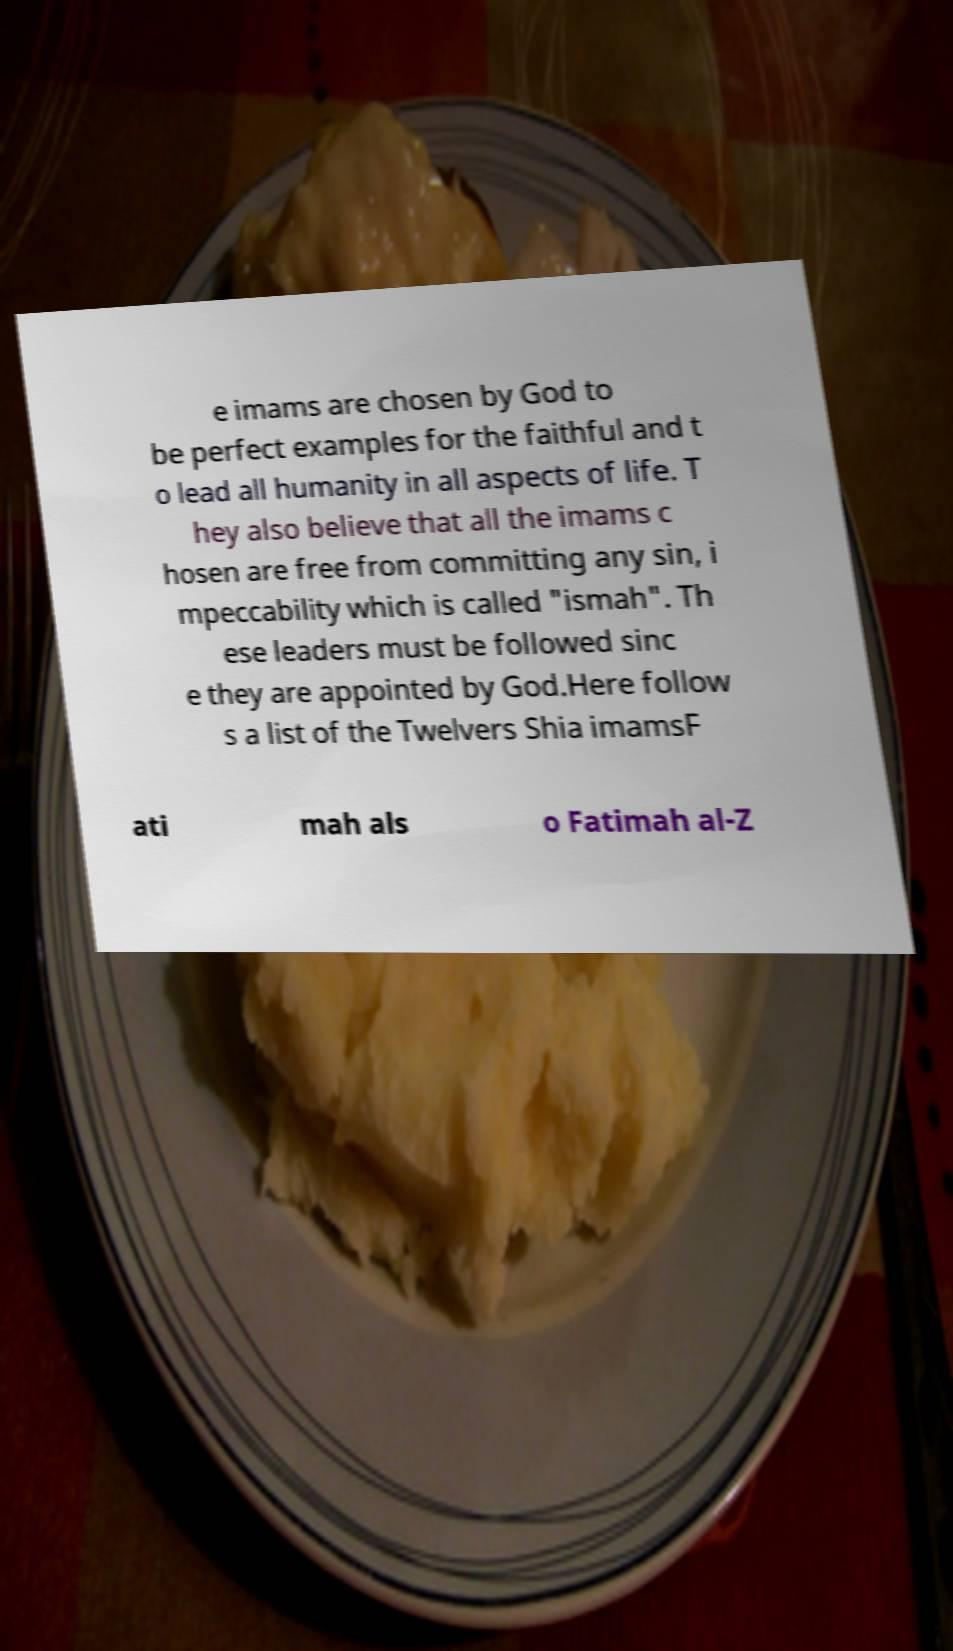There's text embedded in this image that I need extracted. Can you transcribe it verbatim? e imams are chosen by God to be perfect examples for the faithful and t o lead all humanity in all aspects of life. T hey also believe that all the imams c hosen are free from committing any sin, i mpeccability which is called "ismah". Th ese leaders must be followed sinc e they are appointed by God.Here follow s a list of the Twelvers Shia imamsF ati mah als o Fatimah al-Z 